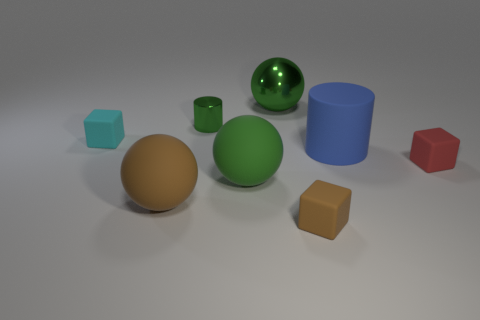Add 2 green metallic cubes. How many objects exist? 10 Subtract all big green shiny balls. How many balls are left? 2 Subtract 2 cylinders. How many cylinders are left? 0 Subtract all blue cylinders. How many cylinders are left? 1 Subtract all purple cylinders. Subtract all green spheres. How many cylinders are left? 2 Subtract all green cylinders. How many purple balls are left? 0 Subtract all balls. Subtract all brown blocks. How many objects are left? 4 Add 3 cylinders. How many cylinders are left? 5 Add 1 small green objects. How many small green objects exist? 2 Subtract 0 purple balls. How many objects are left? 8 